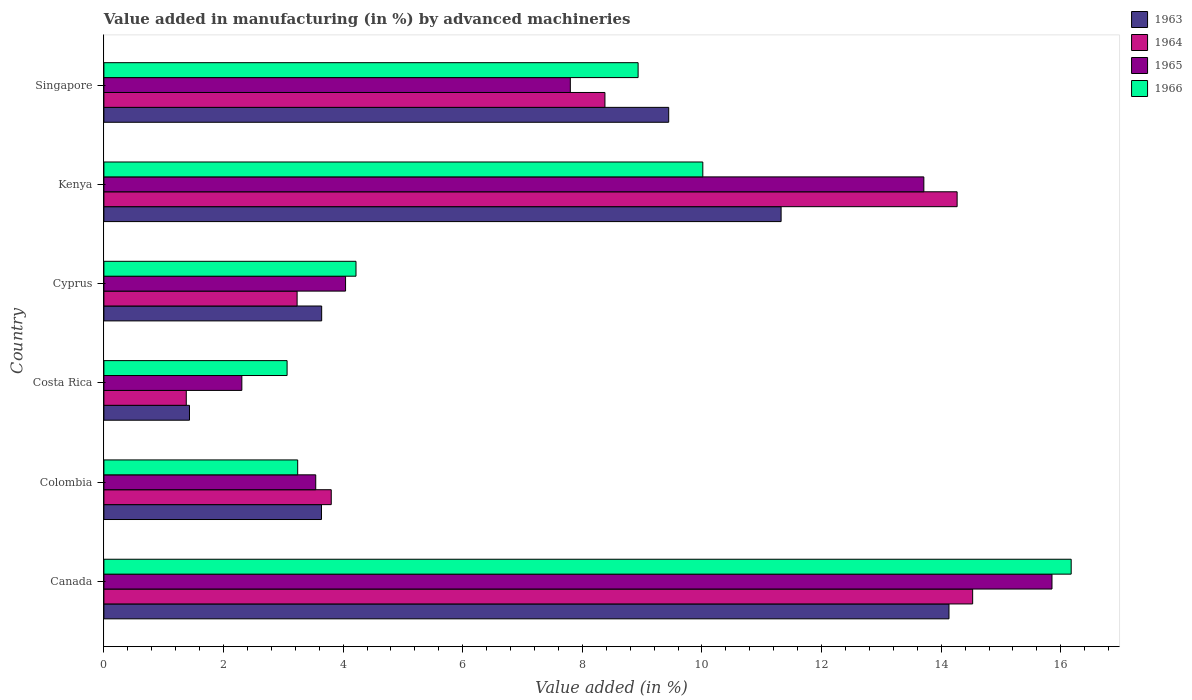Are the number of bars per tick equal to the number of legend labels?
Offer a terse response. Yes. Are the number of bars on each tick of the Y-axis equal?
Your answer should be compact. Yes. How many bars are there on the 5th tick from the bottom?
Provide a succinct answer. 4. What is the label of the 2nd group of bars from the top?
Your answer should be compact. Kenya. What is the percentage of value added in manufacturing by advanced machineries in 1966 in Costa Rica?
Your answer should be compact. 3.06. Across all countries, what is the maximum percentage of value added in manufacturing by advanced machineries in 1963?
Provide a short and direct response. 14.13. Across all countries, what is the minimum percentage of value added in manufacturing by advanced machineries in 1965?
Keep it short and to the point. 2.31. In which country was the percentage of value added in manufacturing by advanced machineries in 1963 minimum?
Ensure brevity in your answer.  Costa Rica. What is the total percentage of value added in manufacturing by advanced machineries in 1966 in the graph?
Provide a short and direct response. 45.64. What is the difference between the percentage of value added in manufacturing by advanced machineries in 1963 in Costa Rica and that in Singapore?
Your response must be concise. -8.01. What is the difference between the percentage of value added in manufacturing by advanced machineries in 1964 in Kenya and the percentage of value added in manufacturing by advanced machineries in 1963 in Cyprus?
Provide a short and direct response. 10.63. What is the average percentage of value added in manufacturing by advanced machineries in 1964 per country?
Your response must be concise. 7.6. What is the difference between the percentage of value added in manufacturing by advanced machineries in 1963 and percentage of value added in manufacturing by advanced machineries in 1966 in Singapore?
Give a very brief answer. 0.51. In how many countries, is the percentage of value added in manufacturing by advanced machineries in 1964 greater than 10.4 %?
Your answer should be compact. 2. What is the ratio of the percentage of value added in manufacturing by advanced machineries in 1964 in Kenya to that in Singapore?
Provide a short and direct response. 1.7. Is the percentage of value added in manufacturing by advanced machineries in 1965 in Colombia less than that in Costa Rica?
Provide a succinct answer. No. What is the difference between the highest and the second highest percentage of value added in manufacturing by advanced machineries in 1964?
Offer a very short reply. 0.26. What is the difference between the highest and the lowest percentage of value added in manufacturing by advanced machineries in 1966?
Make the answer very short. 13.11. What does the 3rd bar from the bottom in Costa Rica represents?
Offer a very short reply. 1965. Is it the case that in every country, the sum of the percentage of value added in manufacturing by advanced machineries in 1964 and percentage of value added in manufacturing by advanced machineries in 1963 is greater than the percentage of value added in manufacturing by advanced machineries in 1965?
Your response must be concise. Yes. How many bars are there?
Your response must be concise. 24. How many countries are there in the graph?
Offer a very short reply. 6. Does the graph contain any zero values?
Provide a short and direct response. No. Does the graph contain grids?
Provide a short and direct response. No. Where does the legend appear in the graph?
Your response must be concise. Top right. How are the legend labels stacked?
Ensure brevity in your answer.  Vertical. What is the title of the graph?
Keep it short and to the point. Value added in manufacturing (in %) by advanced machineries. What is the label or title of the X-axis?
Make the answer very short. Value added (in %). What is the label or title of the Y-axis?
Give a very brief answer. Country. What is the Value added (in %) in 1963 in Canada?
Your answer should be very brief. 14.13. What is the Value added (in %) in 1964 in Canada?
Offer a very short reply. 14.53. What is the Value added (in %) of 1965 in Canada?
Make the answer very short. 15.85. What is the Value added (in %) of 1966 in Canada?
Your answer should be compact. 16.17. What is the Value added (in %) of 1963 in Colombia?
Your response must be concise. 3.64. What is the Value added (in %) of 1964 in Colombia?
Make the answer very short. 3.8. What is the Value added (in %) in 1965 in Colombia?
Make the answer very short. 3.54. What is the Value added (in %) of 1966 in Colombia?
Your answer should be very brief. 3.24. What is the Value added (in %) in 1963 in Costa Rica?
Offer a very short reply. 1.43. What is the Value added (in %) in 1964 in Costa Rica?
Your answer should be very brief. 1.38. What is the Value added (in %) in 1965 in Costa Rica?
Offer a terse response. 2.31. What is the Value added (in %) of 1966 in Costa Rica?
Keep it short and to the point. 3.06. What is the Value added (in %) in 1963 in Cyprus?
Your answer should be very brief. 3.64. What is the Value added (in %) of 1964 in Cyprus?
Provide a succinct answer. 3.23. What is the Value added (in %) of 1965 in Cyprus?
Make the answer very short. 4.04. What is the Value added (in %) of 1966 in Cyprus?
Your response must be concise. 4.22. What is the Value added (in %) of 1963 in Kenya?
Your response must be concise. 11.32. What is the Value added (in %) of 1964 in Kenya?
Offer a terse response. 14.27. What is the Value added (in %) in 1965 in Kenya?
Offer a very short reply. 13.71. What is the Value added (in %) in 1966 in Kenya?
Your response must be concise. 10.01. What is the Value added (in %) of 1963 in Singapore?
Provide a succinct answer. 9.44. What is the Value added (in %) of 1964 in Singapore?
Offer a terse response. 8.38. What is the Value added (in %) in 1965 in Singapore?
Ensure brevity in your answer.  7.8. What is the Value added (in %) of 1966 in Singapore?
Ensure brevity in your answer.  8.93. Across all countries, what is the maximum Value added (in %) of 1963?
Give a very brief answer. 14.13. Across all countries, what is the maximum Value added (in %) in 1964?
Your response must be concise. 14.53. Across all countries, what is the maximum Value added (in %) in 1965?
Offer a terse response. 15.85. Across all countries, what is the maximum Value added (in %) in 1966?
Keep it short and to the point. 16.17. Across all countries, what is the minimum Value added (in %) of 1963?
Offer a very short reply. 1.43. Across all countries, what is the minimum Value added (in %) in 1964?
Keep it short and to the point. 1.38. Across all countries, what is the minimum Value added (in %) in 1965?
Keep it short and to the point. 2.31. Across all countries, what is the minimum Value added (in %) in 1966?
Keep it short and to the point. 3.06. What is the total Value added (in %) in 1963 in the graph?
Offer a very short reply. 43.61. What is the total Value added (in %) in 1964 in the graph?
Make the answer very short. 45.58. What is the total Value added (in %) in 1965 in the graph?
Make the answer very short. 47.25. What is the total Value added (in %) of 1966 in the graph?
Ensure brevity in your answer.  45.64. What is the difference between the Value added (in %) of 1963 in Canada and that in Colombia?
Your response must be concise. 10.49. What is the difference between the Value added (in %) in 1964 in Canada and that in Colombia?
Offer a terse response. 10.72. What is the difference between the Value added (in %) of 1965 in Canada and that in Colombia?
Your answer should be compact. 12.31. What is the difference between the Value added (in %) of 1966 in Canada and that in Colombia?
Offer a very short reply. 12.93. What is the difference between the Value added (in %) of 1963 in Canada and that in Costa Rica?
Keep it short and to the point. 12.7. What is the difference between the Value added (in %) of 1964 in Canada and that in Costa Rica?
Your answer should be compact. 13.15. What is the difference between the Value added (in %) of 1965 in Canada and that in Costa Rica?
Ensure brevity in your answer.  13.55. What is the difference between the Value added (in %) in 1966 in Canada and that in Costa Rica?
Ensure brevity in your answer.  13.11. What is the difference between the Value added (in %) of 1963 in Canada and that in Cyprus?
Provide a succinct answer. 10.49. What is the difference between the Value added (in %) of 1964 in Canada and that in Cyprus?
Offer a terse response. 11.3. What is the difference between the Value added (in %) of 1965 in Canada and that in Cyprus?
Ensure brevity in your answer.  11.81. What is the difference between the Value added (in %) of 1966 in Canada and that in Cyprus?
Make the answer very short. 11.96. What is the difference between the Value added (in %) of 1963 in Canada and that in Kenya?
Keep it short and to the point. 2.81. What is the difference between the Value added (in %) in 1964 in Canada and that in Kenya?
Offer a terse response. 0.26. What is the difference between the Value added (in %) in 1965 in Canada and that in Kenya?
Your answer should be very brief. 2.14. What is the difference between the Value added (in %) in 1966 in Canada and that in Kenya?
Make the answer very short. 6.16. What is the difference between the Value added (in %) in 1963 in Canada and that in Singapore?
Keep it short and to the point. 4.69. What is the difference between the Value added (in %) in 1964 in Canada and that in Singapore?
Offer a very short reply. 6.15. What is the difference between the Value added (in %) in 1965 in Canada and that in Singapore?
Make the answer very short. 8.05. What is the difference between the Value added (in %) of 1966 in Canada and that in Singapore?
Give a very brief answer. 7.24. What is the difference between the Value added (in %) in 1963 in Colombia and that in Costa Rica?
Offer a terse response. 2.21. What is the difference between the Value added (in %) of 1964 in Colombia and that in Costa Rica?
Give a very brief answer. 2.42. What is the difference between the Value added (in %) of 1965 in Colombia and that in Costa Rica?
Your answer should be very brief. 1.24. What is the difference between the Value added (in %) of 1966 in Colombia and that in Costa Rica?
Your response must be concise. 0.18. What is the difference between the Value added (in %) of 1963 in Colombia and that in Cyprus?
Offer a terse response. -0. What is the difference between the Value added (in %) in 1964 in Colombia and that in Cyprus?
Provide a succinct answer. 0.57. What is the difference between the Value added (in %) in 1965 in Colombia and that in Cyprus?
Provide a short and direct response. -0.5. What is the difference between the Value added (in %) of 1966 in Colombia and that in Cyprus?
Your answer should be compact. -0.97. What is the difference between the Value added (in %) in 1963 in Colombia and that in Kenya?
Provide a succinct answer. -7.69. What is the difference between the Value added (in %) in 1964 in Colombia and that in Kenya?
Offer a terse response. -10.47. What is the difference between the Value added (in %) in 1965 in Colombia and that in Kenya?
Ensure brevity in your answer.  -10.17. What is the difference between the Value added (in %) in 1966 in Colombia and that in Kenya?
Provide a short and direct response. -6.77. What is the difference between the Value added (in %) in 1963 in Colombia and that in Singapore?
Offer a terse response. -5.81. What is the difference between the Value added (in %) in 1964 in Colombia and that in Singapore?
Provide a short and direct response. -4.58. What is the difference between the Value added (in %) in 1965 in Colombia and that in Singapore?
Provide a succinct answer. -4.26. What is the difference between the Value added (in %) of 1966 in Colombia and that in Singapore?
Your answer should be compact. -5.69. What is the difference between the Value added (in %) of 1963 in Costa Rica and that in Cyprus?
Provide a short and direct response. -2.21. What is the difference between the Value added (in %) in 1964 in Costa Rica and that in Cyprus?
Give a very brief answer. -1.85. What is the difference between the Value added (in %) in 1965 in Costa Rica and that in Cyprus?
Provide a short and direct response. -1.73. What is the difference between the Value added (in %) in 1966 in Costa Rica and that in Cyprus?
Ensure brevity in your answer.  -1.15. What is the difference between the Value added (in %) of 1963 in Costa Rica and that in Kenya?
Your response must be concise. -9.89. What is the difference between the Value added (in %) of 1964 in Costa Rica and that in Kenya?
Ensure brevity in your answer.  -12.89. What is the difference between the Value added (in %) of 1965 in Costa Rica and that in Kenya?
Make the answer very short. -11.4. What is the difference between the Value added (in %) of 1966 in Costa Rica and that in Kenya?
Provide a succinct answer. -6.95. What is the difference between the Value added (in %) in 1963 in Costa Rica and that in Singapore?
Provide a succinct answer. -8.01. What is the difference between the Value added (in %) in 1964 in Costa Rica and that in Singapore?
Provide a short and direct response. -7. What is the difference between the Value added (in %) of 1965 in Costa Rica and that in Singapore?
Provide a short and direct response. -5.49. What is the difference between the Value added (in %) in 1966 in Costa Rica and that in Singapore?
Provide a succinct answer. -5.87. What is the difference between the Value added (in %) of 1963 in Cyprus and that in Kenya?
Your answer should be very brief. -7.68. What is the difference between the Value added (in %) in 1964 in Cyprus and that in Kenya?
Keep it short and to the point. -11.04. What is the difference between the Value added (in %) in 1965 in Cyprus and that in Kenya?
Your answer should be very brief. -9.67. What is the difference between the Value added (in %) of 1966 in Cyprus and that in Kenya?
Keep it short and to the point. -5.8. What is the difference between the Value added (in %) in 1963 in Cyprus and that in Singapore?
Keep it short and to the point. -5.8. What is the difference between the Value added (in %) in 1964 in Cyprus and that in Singapore?
Offer a terse response. -5.15. What is the difference between the Value added (in %) of 1965 in Cyprus and that in Singapore?
Offer a terse response. -3.76. What is the difference between the Value added (in %) of 1966 in Cyprus and that in Singapore?
Your response must be concise. -4.72. What is the difference between the Value added (in %) in 1963 in Kenya and that in Singapore?
Make the answer very short. 1.88. What is the difference between the Value added (in %) in 1964 in Kenya and that in Singapore?
Ensure brevity in your answer.  5.89. What is the difference between the Value added (in %) in 1965 in Kenya and that in Singapore?
Ensure brevity in your answer.  5.91. What is the difference between the Value added (in %) in 1966 in Kenya and that in Singapore?
Ensure brevity in your answer.  1.08. What is the difference between the Value added (in %) in 1963 in Canada and the Value added (in %) in 1964 in Colombia?
Provide a succinct answer. 10.33. What is the difference between the Value added (in %) of 1963 in Canada and the Value added (in %) of 1965 in Colombia?
Your answer should be very brief. 10.59. What is the difference between the Value added (in %) of 1963 in Canada and the Value added (in %) of 1966 in Colombia?
Offer a very short reply. 10.89. What is the difference between the Value added (in %) of 1964 in Canada and the Value added (in %) of 1965 in Colombia?
Provide a short and direct response. 10.98. What is the difference between the Value added (in %) of 1964 in Canada and the Value added (in %) of 1966 in Colombia?
Ensure brevity in your answer.  11.29. What is the difference between the Value added (in %) in 1965 in Canada and the Value added (in %) in 1966 in Colombia?
Keep it short and to the point. 12.61. What is the difference between the Value added (in %) in 1963 in Canada and the Value added (in %) in 1964 in Costa Rica?
Your answer should be compact. 12.75. What is the difference between the Value added (in %) of 1963 in Canada and the Value added (in %) of 1965 in Costa Rica?
Provide a short and direct response. 11.82. What is the difference between the Value added (in %) in 1963 in Canada and the Value added (in %) in 1966 in Costa Rica?
Offer a terse response. 11.07. What is the difference between the Value added (in %) of 1964 in Canada and the Value added (in %) of 1965 in Costa Rica?
Offer a terse response. 12.22. What is the difference between the Value added (in %) of 1964 in Canada and the Value added (in %) of 1966 in Costa Rica?
Make the answer very short. 11.46. What is the difference between the Value added (in %) of 1965 in Canada and the Value added (in %) of 1966 in Costa Rica?
Offer a very short reply. 12.79. What is the difference between the Value added (in %) in 1963 in Canada and the Value added (in %) in 1964 in Cyprus?
Offer a terse response. 10.9. What is the difference between the Value added (in %) of 1963 in Canada and the Value added (in %) of 1965 in Cyprus?
Offer a terse response. 10.09. What is the difference between the Value added (in %) of 1963 in Canada and the Value added (in %) of 1966 in Cyprus?
Provide a short and direct response. 9.92. What is the difference between the Value added (in %) of 1964 in Canada and the Value added (in %) of 1965 in Cyprus?
Provide a succinct answer. 10.49. What is the difference between the Value added (in %) in 1964 in Canada and the Value added (in %) in 1966 in Cyprus?
Provide a short and direct response. 10.31. What is the difference between the Value added (in %) in 1965 in Canada and the Value added (in %) in 1966 in Cyprus?
Offer a very short reply. 11.64. What is the difference between the Value added (in %) in 1963 in Canada and the Value added (in %) in 1964 in Kenya?
Offer a very short reply. -0.14. What is the difference between the Value added (in %) of 1963 in Canada and the Value added (in %) of 1965 in Kenya?
Keep it short and to the point. 0.42. What is the difference between the Value added (in %) in 1963 in Canada and the Value added (in %) in 1966 in Kenya?
Your answer should be compact. 4.12. What is the difference between the Value added (in %) of 1964 in Canada and the Value added (in %) of 1965 in Kenya?
Keep it short and to the point. 0.82. What is the difference between the Value added (in %) of 1964 in Canada and the Value added (in %) of 1966 in Kenya?
Give a very brief answer. 4.51. What is the difference between the Value added (in %) in 1965 in Canada and the Value added (in %) in 1966 in Kenya?
Keep it short and to the point. 5.84. What is the difference between the Value added (in %) of 1963 in Canada and the Value added (in %) of 1964 in Singapore?
Offer a terse response. 5.75. What is the difference between the Value added (in %) of 1963 in Canada and the Value added (in %) of 1965 in Singapore?
Your response must be concise. 6.33. What is the difference between the Value added (in %) in 1963 in Canada and the Value added (in %) in 1966 in Singapore?
Make the answer very short. 5.2. What is the difference between the Value added (in %) of 1964 in Canada and the Value added (in %) of 1965 in Singapore?
Your response must be concise. 6.73. What is the difference between the Value added (in %) of 1964 in Canada and the Value added (in %) of 1966 in Singapore?
Give a very brief answer. 5.59. What is the difference between the Value added (in %) in 1965 in Canada and the Value added (in %) in 1966 in Singapore?
Make the answer very short. 6.92. What is the difference between the Value added (in %) of 1963 in Colombia and the Value added (in %) of 1964 in Costa Rica?
Your answer should be compact. 2.26. What is the difference between the Value added (in %) in 1963 in Colombia and the Value added (in %) in 1965 in Costa Rica?
Offer a very short reply. 1.33. What is the difference between the Value added (in %) in 1963 in Colombia and the Value added (in %) in 1966 in Costa Rica?
Offer a terse response. 0.57. What is the difference between the Value added (in %) in 1964 in Colombia and the Value added (in %) in 1965 in Costa Rica?
Your answer should be very brief. 1.49. What is the difference between the Value added (in %) in 1964 in Colombia and the Value added (in %) in 1966 in Costa Rica?
Ensure brevity in your answer.  0.74. What is the difference between the Value added (in %) of 1965 in Colombia and the Value added (in %) of 1966 in Costa Rica?
Your answer should be compact. 0.48. What is the difference between the Value added (in %) in 1963 in Colombia and the Value added (in %) in 1964 in Cyprus?
Your answer should be very brief. 0.41. What is the difference between the Value added (in %) of 1963 in Colombia and the Value added (in %) of 1965 in Cyprus?
Make the answer very short. -0.4. What is the difference between the Value added (in %) of 1963 in Colombia and the Value added (in %) of 1966 in Cyprus?
Your answer should be very brief. -0.58. What is the difference between the Value added (in %) of 1964 in Colombia and the Value added (in %) of 1965 in Cyprus?
Provide a short and direct response. -0.24. What is the difference between the Value added (in %) of 1964 in Colombia and the Value added (in %) of 1966 in Cyprus?
Provide a succinct answer. -0.41. What is the difference between the Value added (in %) of 1965 in Colombia and the Value added (in %) of 1966 in Cyprus?
Your answer should be compact. -0.67. What is the difference between the Value added (in %) of 1963 in Colombia and the Value added (in %) of 1964 in Kenya?
Provide a short and direct response. -10.63. What is the difference between the Value added (in %) in 1963 in Colombia and the Value added (in %) in 1965 in Kenya?
Offer a very short reply. -10.07. What is the difference between the Value added (in %) in 1963 in Colombia and the Value added (in %) in 1966 in Kenya?
Ensure brevity in your answer.  -6.38. What is the difference between the Value added (in %) of 1964 in Colombia and the Value added (in %) of 1965 in Kenya?
Your response must be concise. -9.91. What is the difference between the Value added (in %) in 1964 in Colombia and the Value added (in %) in 1966 in Kenya?
Make the answer very short. -6.21. What is the difference between the Value added (in %) in 1965 in Colombia and the Value added (in %) in 1966 in Kenya?
Make the answer very short. -6.47. What is the difference between the Value added (in %) in 1963 in Colombia and the Value added (in %) in 1964 in Singapore?
Your answer should be compact. -4.74. What is the difference between the Value added (in %) in 1963 in Colombia and the Value added (in %) in 1965 in Singapore?
Provide a succinct answer. -4.16. What is the difference between the Value added (in %) in 1963 in Colombia and the Value added (in %) in 1966 in Singapore?
Offer a terse response. -5.29. What is the difference between the Value added (in %) of 1964 in Colombia and the Value added (in %) of 1965 in Singapore?
Offer a terse response. -4. What is the difference between the Value added (in %) of 1964 in Colombia and the Value added (in %) of 1966 in Singapore?
Offer a very short reply. -5.13. What is the difference between the Value added (in %) in 1965 in Colombia and the Value added (in %) in 1966 in Singapore?
Provide a succinct answer. -5.39. What is the difference between the Value added (in %) in 1963 in Costa Rica and the Value added (in %) in 1964 in Cyprus?
Provide a succinct answer. -1.8. What is the difference between the Value added (in %) of 1963 in Costa Rica and the Value added (in %) of 1965 in Cyprus?
Offer a very short reply. -2.61. What is the difference between the Value added (in %) in 1963 in Costa Rica and the Value added (in %) in 1966 in Cyprus?
Ensure brevity in your answer.  -2.78. What is the difference between the Value added (in %) of 1964 in Costa Rica and the Value added (in %) of 1965 in Cyprus?
Provide a short and direct response. -2.66. What is the difference between the Value added (in %) in 1964 in Costa Rica and the Value added (in %) in 1966 in Cyprus?
Make the answer very short. -2.84. What is the difference between the Value added (in %) of 1965 in Costa Rica and the Value added (in %) of 1966 in Cyprus?
Your response must be concise. -1.91. What is the difference between the Value added (in %) of 1963 in Costa Rica and the Value added (in %) of 1964 in Kenya?
Make the answer very short. -12.84. What is the difference between the Value added (in %) of 1963 in Costa Rica and the Value added (in %) of 1965 in Kenya?
Offer a terse response. -12.28. What is the difference between the Value added (in %) in 1963 in Costa Rica and the Value added (in %) in 1966 in Kenya?
Your answer should be very brief. -8.58. What is the difference between the Value added (in %) of 1964 in Costa Rica and the Value added (in %) of 1965 in Kenya?
Offer a very short reply. -12.33. What is the difference between the Value added (in %) in 1964 in Costa Rica and the Value added (in %) in 1966 in Kenya?
Provide a short and direct response. -8.64. What is the difference between the Value added (in %) in 1965 in Costa Rica and the Value added (in %) in 1966 in Kenya?
Provide a short and direct response. -7.71. What is the difference between the Value added (in %) of 1963 in Costa Rica and the Value added (in %) of 1964 in Singapore?
Offer a very short reply. -6.95. What is the difference between the Value added (in %) in 1963 in Costa Rica and the Value added (in %) in 1965 in Singapore?
Offer a terse response. -6.37. What is the difference between the Value added (in %) in 1963 in Costa Rica and the Value added (in %) in 1966 in Singapore?
Your answer should be very brief. -7.5. What is the difference between the Value added (in %) of 1964 in Costa Rica and the Value added (in %) of 1965 in Singapore?
Offer a very short reply. -6.42. What is the difference between the Value added (in %) of 1964 in Costa Rica and the Value added (in %) of 1966 in Singapore?
Offer a terse response. -7.55. What is the difference between the Value added (in %) of 1965 in Costa Rica and the Value added (in %) of 1966 in Singapore?
Your answer should be compact. -6.63. What is the difference between the Value added (in %) in 1963 in Cyprus and the Value added (in %) in 1964 in Kenya?
Provide a succinct answer. -10.63. What is the difference between the Value added (in %) of 1963 in Cyprus and the Value added (in %) of 1965 in Kenya?
Your answer should be very brief. -10.07. What is the difference between the Value added (in %) of 1963 in Cyprus and the Value added (in %) of 1966 in Kenya?
Make the answer very short. -6.37. What is the difference between the Value added (in %) of 1964 in Cyprus and the Value added (in %) of 1965 in Kenya?
Give a very brief answer. -10.48. What is the difference between the Value added (in %) in 1964 in Cyprus and the Value added (in %) in 1966 in Kenya?
Ensure brevity in your answer.  -6.78. What is the difference between the Value added (in %) of 1965 in Cyprus and the Value added (in %) of 1966 in Kenya?
Ensure brevity in your answer.  -5.97. What is the difference between the Value added (in %) of 1963 in Cyprus and the Value added (in %) of 1964 in Singapore?
Ensure brevity in your answer.  -4.74. What is the difference between the Value added (in %) of 1963 in Cyprus and the Value added (in %) of 1965 in Singapore?
Your response must be concise. -4.16. What is the difference between the Value added (in %) in 1963 in Cyprus and the Value added (in %) in 1966 in Singapore?
Your response must be concise. -5.29. What is the difference between the Value added (in %) in 1964 in Cyprus and the Value added (in %) in 1965 in Singapore?
Offer a terse response. -4.57. What is the difference between the Value added (in %) in 1964 in Cyprus and the Value added (in %) in 1966 in Singapore?
Provide a succinct answer. -5.7. What is the difference between the Value added (in %) in 1965 in Cyprus and the Value added (in %) in 1966 in Singapore?
Give a very brief answer. -4.89. What is the difference between the Value added (in %) in 1963 in Kenya and the Value added (in %) in 1964 in Singapore?
Provide a succinct answer. 2.95. What is the difference between the Value added (in %) of 1963 in Kenya and the Value added (in %) of 1965 in Singapore?
Keep it short and to the point. 3.52. What is the difference between the Value added (in %) of 1963 in Kenya and the Value added (in %) of 1966 in Singapore?
Give a very brief answer. 2.39. What is the difference between the Value added (in %) of 1964 in Kenya and the Value added (in %) of 1965 in Singapore?
Ensure brevity in your answer.  6.47. What is the difference between the Value added (in %) of 1964 in Kenya and the Value added (in %) of 1966 in Singapore?
Provide a short and direct response. 5.33. What is the difference between the Value added (in %) of 1965 in Kenya and the Value added (in %) of 1966 in Singapore?
Make the answer very short. 4.78. What is the average Value added (in %) in 1963 per country?
Offer a terse response. 7.27. What is the average Value added (in %) in 1964 per country?
Make the answer very short. 7.6. What is the average Value added (in %) of 1965 per country?
Make the answer very short. 7.88. What is the average Value added (in %) in 1966 per country?
Ensure brevity in your answer.  7.61. What is the difference between the Value added (in %) of 1963 and Value added (in %) of 1964 in Canada?
Your answer should be compact. -0.4. What is the difference between the Value added (in %) of 1963 and Value added (in %) of 1965 in Canada?
Make the answer very short. -1.72. What is the difference between the Value added (in %) of 1963 and Value added (in %) of 1966 in Canada?
Your response must be concise. -2.04. What is the difference between the Value added (in %) in 1964 and Value added (in %) in 1965 in Canada?
Your answer should be compact. -1.33. What is the difference between the Value added (in %) of 1964 and Value added (in %) of 1966 in Canada?
Keep it short and to the point. -1.65. What is the difference between the Value added (in %) of 1965 and Value added (in %) of 1966 in Canada?
Provide a succinct answer. -0.32. What is the difference between the Value added (in %) of 1963 and Value added (in %) of 1964 in Colombia?
Keep it short and to the point. -0.16. What is the difference between the Value added (in %) of 1963 and Value added (in %) of 1965 in Colombia?
Offer a terse response. 0.1. What is the difference between the Value added (in %) of 1963 and Value added (in %) of 1966 in Colombia?
Offer a very short reply. 0.4. What is the difference between the Value added (in %) in 1964 and Value added (in %) in 1965 in Colombia?
Ensure brevity in your answer.  0.26. What is the difference between the Value added (in %) of 1964 and Value added (in %) of 1966 in Colombia?
Offer a very short reply. 0.56. What is the difference between the Value added (in %) in 1965 and Value added (in %) in 1966 in Colombia?
Your answer should be compact. 0.3. What is the difference between the Value added (in %) of 1963 and Value added (in %) of 1964 in Costa Rica?
Offer a very short reply. 0.05. What is the difference between the Value added (in %) in 1963 and Value added (in %) in 1965 in Costa Rica?
Offer a terse response. -0.88. What is the difference between the Value added (in %) of 1963 and Value added (in %) of 1966 in Costa Rica?
Provide a succinct answer. -1.63. What is the difference between the Value added (in %) of 1964 and Value added (in %) of 1965 in Costa Rica?
Make the answer very short. -0.93. What is the difference between the Value added (in %) of 1964 and Value added (in %) of 1966 in Costa Rica?
Keep it short and to the point. -1.69. What is the difference between the Value added (in %) of 1965 and Value added (in %) of 1966 in Costa Rica?
Your answer should be compact. -0.76. What is the difference between the Value added (in %) of 1963 and Value added (in %) of 1964 in Cyprus?
Your answer should be very brief. 0.41. What is the difference between the Value added (in %) of 1963 and Value added (in %) of 1965 in Cyprus?
Make the answer very short. -0.4. What is the difference between the Value added (in %) of 1963 and Value added (in %) of 1966 in Cyprus?
Offer a very short reply. -0.57. What is the difference between the Value added (in %) of 1964 and Value added (in %) of 1965 in Cyprus?
Offer a terse response. -0.81. What is the difference between the Value added (in %) of 1964 and Value added (in %) of 1966 in Cyprus?
Offer a very short reply. -0.98. What is the difference between the Value added (in %) in 1965 and Value added (in %) in 1966 in Cyprus?
Your answer should be compact. -0.17. What is the difference between the Value added (in %) of 1963 and Value added (in %) of 1964 in Kenya?
Provide a succinct answer. -2.94. What is the difference between the Value added (in %) of 1963 and Value added (in %) of 1965 in Kenya?
Make the answer very short. -2.39. What is the difference between the Value added (in %) in 1963 and Value added (in %) in 1966 in Kenya?
Make the answer very short. 1.31. What is the difference between the Value added (in %) of 1964 and Value added (in %) of 1965 in Kenya?
Offer a terse response. 0.56. What is the difference between the Value added (in %) in 1964 and Value added (in %) in 1966 in Kenya?
Your answer should be compact. 4.25. What is the difference between the Value added (in %) of 1965 and Value added (in %) of 1966 in Kenya?
Make the answer very short. 3.7. What is the difference between the Value added (in %) in 1963 and Value added (in %) in 1964 in Singapore?
Your answer should be very brief. 1.07. What is the difference between the Value added (in %) of 1963 and Value added (in %) of 1965 in Singapore?
Offer a terse response. 1.64. What is the difference between the Value added (in %) of 1963 and Value added (in %) of 1966 in Singapore?
Offer a terse response. 0.51. What is the difference between the Value added (in %) of 1964 and Value added (in %) of 1965 in Singapore?
Your response must be concise. 0.58. What is the difference between the Value added (in %) in 1964 and Value added (in %) in 1966 in Singapore?
Ensure brevity in your answer.  -0.55. What is the difference between the Value added (in %) of 1965 and Value added (in %) of 1966 in Singapore?
Keep it short and to the point. -1.13. What is the ratio of the Value added (in %) of 1963 in Canada to that in Colombia?
Make the answer very short. 3.88. What is the ratio of the Value added (in %) of 1964 in Canada to that in Colombia?
Provide a succinct answer. 3.82. What is the ratio of the Value added (in %) in 1965 in Canada to that in Colombia?
Provide a succinct answer. 4.48. What is the ratio of the Value added (in %) in 1966 in Canada to that in Colombia?
Give a very brief answer. 4.99. What is the ratio of the Value added (in %) in 1963 in Canada to that in Costa Rica?
Provide a short and direct response. 9.87. What is the ratio of the Value added (in %) in 1964 in Canada to that in Costa Rica?
Ensure brevity in your answer.  10.54. What is the ratio of the Value added (in %) of 1965 in Canada to that in Costa Rica?
Ensure brevity in your answer.  6.87. What is the ratio of the Value added (in %) of 1966 in Canada to that in Costa Rica?
Offer a very short reply. 5.28. What is the ratio of the Value added (in %) in 1963 in Canada to that in Cyprus?
Offer a very short reply. 3.88. What is the ratio of the Value added (in %) of 1964 in Canada to that in Cyprus?
Make the answer very short. 4.5. What is the ratio of the Value added (in %) of 1965 in Canada to that in Cyprus?
Give a very brief answer. 3.92. What is the ratio of the Value added (in %) of 1966 in Canada to that in Cyprus?
Provide a short and direct response. 3.84. What is the ratio of the Value added (in %) of 1963 in Canada to that in Kenya?
Ensure brevity in your answer.  1.25. What is the ratio of the Value added (in %) in 1964 in Canada to that in Kenya?
Offer a very short reply. 1.02. What is the ratio of the Value added (in %) of 1965 in Canada to that in Kenya?
Keep it short and to the point. 1.16. What is the ratio of the Value added (in %) in 1966 in Canada to that in Kenya?
Your answer should be compact. 1.62. What is the ratio of the Value added (in %) of 1963 in Canada to that in Singapore?
Your answer should be very brief. 1.5. What is the ratio of the Value added (in %) of 1964 in Canada to that in Singapore?
Your response must be concise. 1.73. What is the ratio of the Value added (in %) in 1965 in Canada to that in Singapore?
Your response must be concise. 2.03. What is the ratio of the Value added (in %) in 1966 in Canada to that in Singapore?
Keep it short and to the point. 1.81. What is the ratio of the Value added (in %) of 1963 in Colombia to that in Costa Rica?
Offer a very short reply. 2.54. What is the ratio of the Value added (in %) of 1964 in Colombia to that in Costa Rica?
Give a very brief answer. 2.76. What is the ratio of the Value added (in %) in 1965 in Colombia to that in Costa Rica?
Offer a very short reply. 1.54. What is the ratio of the Value added (in %) in 1966 in Colombia to that in Costa Rica?
Make the answer very short. 1.06. What is the ratio of the Value added (in %) in 1963 in Colombia to that in Cyprus?
Your answer should be compact. 1. What is the ratio of the Value added (in %) in 1964 in Colombia to that in Cyprus?
Your answer should be compact. 1.18. What is the ratio of the Value added (in %) of 1965 in Colombia to that in Cyprus?
Your answer should be very brief. 0.88. What is the ratio of the Value added (in %) in 1966 in Colombia to that in Cyprus?
Provide a succinct answer. 0.77. What is the ratio of the Value added (in %) in 1963 in Colombia to that in Kenya?
Offer a very short reply. 0.32. What is the ratio of the Value added (in %) in 1964 in Colombia to that in Kenya?
Ensure brevity in your answer.  0.27. What is the ratio of the Value added (in %) in 1965 in Colombia to that in Kenya?
Give a very brief answer. 0.26. What is the ratio of the Value added (in %) of 1966 in Colombia to that in Kenya?
Provide a short and direct response. 0.32. What is the ratio of the Value added (in %) of 1963 in Colombia to that in Singapore?
Give a very brief answer. 0.39. What is the ratio of the Value added (in %) of 1964 in Colombia to that in Singapore?
Make the answer very short. 0.45. What is the ratio of the Value added (in %) of 1965 in Colombia to that in Singapore?
Keep it short and to the point. 0.45. What is the ratio of the Value added (in %) of 1966 in Colombia to that in Singapore?
Make the answer very short. 0.36. What is the ratio of the Value added (in %) of 1963 in Costa Rica to that in Cyprus?
Offer a terse response. 0.39. What is the ratio of the Value added (in %) of 1964 in Costa Rica to that in Cyprus?
Your answer should be compact. 0.43. What is the ratio of the Value added (in %) in 1965 in Costa Rica to that in Cyprus?
Ensure brevity in your answer.  0.57. What is the ratio of the Value added (in %) of 1966 in Costa Rica to that in Cyprus?
Make the answer very short. 0.73. What is the ratio of the Value added (in %) of 1963 in Costa Rica to that in Kenya?
Offer a very short reply. 0.13. What is the ratio of the Value added (in %) in 1964 in Costa Rica to that in Kenya?
Your response must be concise. 0.1. What is the ratio of the Value added (in %) in 1965 in Costa Rica to that in Kenya?
Offer a terse response. 0.17. What is the ratio of the Value added (in %) of 1966 in Costa Rica to that in Kenya?
Ensure brevity in your answer.  0.31. What is the ratio of the Value added (in %) of 1963 in Costa Rica to that in Singapore?
Give a very brief answer. 0.15. What is the ratio of the Value added (in %) of 1964 in Costa Rica to that in Singapore?
Keep it short and to the point. 0.16. What is the ratio of the Value added (in %) of 1965 in Costa Rica to that in Singapore?
Your response must be concise. 0.3. What is the ratio of the Value added (in %) in 1966 in Costa Rica to that in Singapore?
Provide a short and direct response. 0.34. What is the ratio of the Value added (in %) in 1963 in Cyprus to that in Kenya?
Offer a terse response. 0.32. What is the ratio of the Value added (in %) in 1964 in Cyprus to that in Kenya?
Offer a very short reply. 0.23. What is the ratio of the Value added (in %) of 1965 in Cyprus to that in Kenya?
Make the answer very short. 0.29. What is the ratio of the Value added (in %) of 1966 in Cyprus to that in Kenya?
Your answer should be very brief. 0.42. What is the ratio of the Value added (in %) in 1963 in Cyprus to that in Singapore?
Your answer should be very brief. 0.39. What is the ratio of the Value added (in %) of 1964 in Cyprus to that in Singapore?
Your answer should be very brief. 0.39. What is the ratio of the Value added (in %) of 1965 in Cyprus to that in Singapore?
Offer a very short reply. 0.52. What is the ratio of the Value added (in %) of 1966 in Cyprus to that in Singapore?
Your answer should be very brief. 0.47. What is the ratio of the Value added (in %) of 1963 in Kenya to that in Singapore?
Keep it short and to the point. 1.2. What is the ratio of the Value added (in %) of 1964 in Kenya to that in Singapore?
Keep it short and to the point. 1.7. What is the ratio of the Value added (in %) in 1965 in Kenya to that in Singapore?
Make the answer very short. 1.76. What is the ratio of the Value added (in %) in 1966 in Kenya to that in Singapore?
Offer a terse response. 1.12. What is the difference between the highest and the second highest Value added (in %) in 1963?
Make the answer very short. 2.81. What is the difference between the highest and the second highest Value added (in %) in 1964?
Provide a succinct answer. 0.26. What is the difference between the highest and the second highest Value added (in %) in 1965?
Your response must be concise. 2.14. What is the difference between the highest and the second highest Value added (in %) in 1966?
Provide a succinct answer. 6.16. What is the difference between the highest and the lowest Value added (in %) of 1963?
Make the answer very short. 12.7. What is the difference between the highest and the lowest Value added (in %) in 1964?
Provide a succinct answer. 13.15. What is the difference between the highest and the lowest Value added (in %) in 1965?
Keep it short and to the point. 13.55. What is the difference between the highest and the lowest Value added (in %) in 1966?
Your response must be concise. 13.11. 